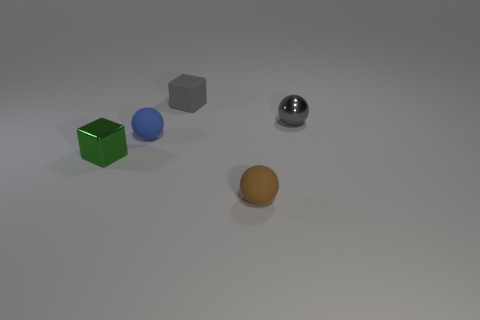How many small objects are either gray objects or cyan matte blocks?
Provide a short and direct response. 2. The matte object that is the same color as the metal ball is what shape?
Your response must be concise. Cube. Are the brown sphere that is to the right of the shiny cube and the small green thing made of the same material?
Ensure brevity in your answer.  No. There is a block in front of the tiny matte sphere that is behind the tiny green cube; what is its material?
Offer a very short reply. Metal. How many other metallic things have the same shape as the tiny brown thing?
Make the answer very short. 1. What size is the rubber sphere behind the tiny shiny object on the left side of the small ball that is behind the small blue ball?
Provide a short and direct response. Small. What number of red things are either spheres or tiny matte things?
Make the answer very short. 0. Does the metal thing that is behind the blue matte thing have the same shape as the brown object?
Provide a succinct answer. Yes. Are there more brown rubber balls that are right of the small shiny ball than large gray shiny cubes?
Make the answer very short. No. How many green objects have the same size as the blue rubber thing?
Ensure brevity in your answer.  1. 